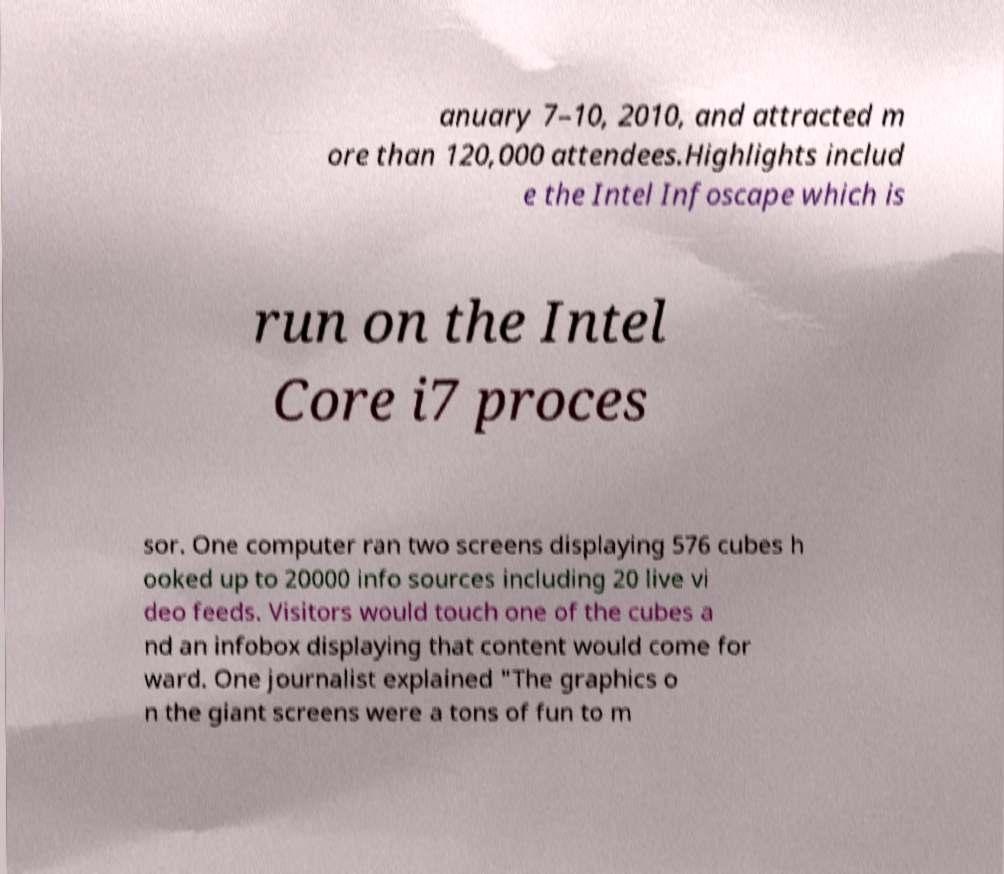Can you accurately transcribe the text from the provided image for me? anuary 7–10, 2010, and attracted m ore than 120,000 attendees.Highlights includ e the Intel Infoscape which is run on the Intel Core i7 proces sor. One computer ran two screens displaying 576 cubes h ooked up to 20000 info sources including 20 live vi deo feeds. Visitors would touch one of the cubes a nd an infobox displaying that content would come for ward. One journalist explained "The graphics o n the giant screens were a tons of fun to m 